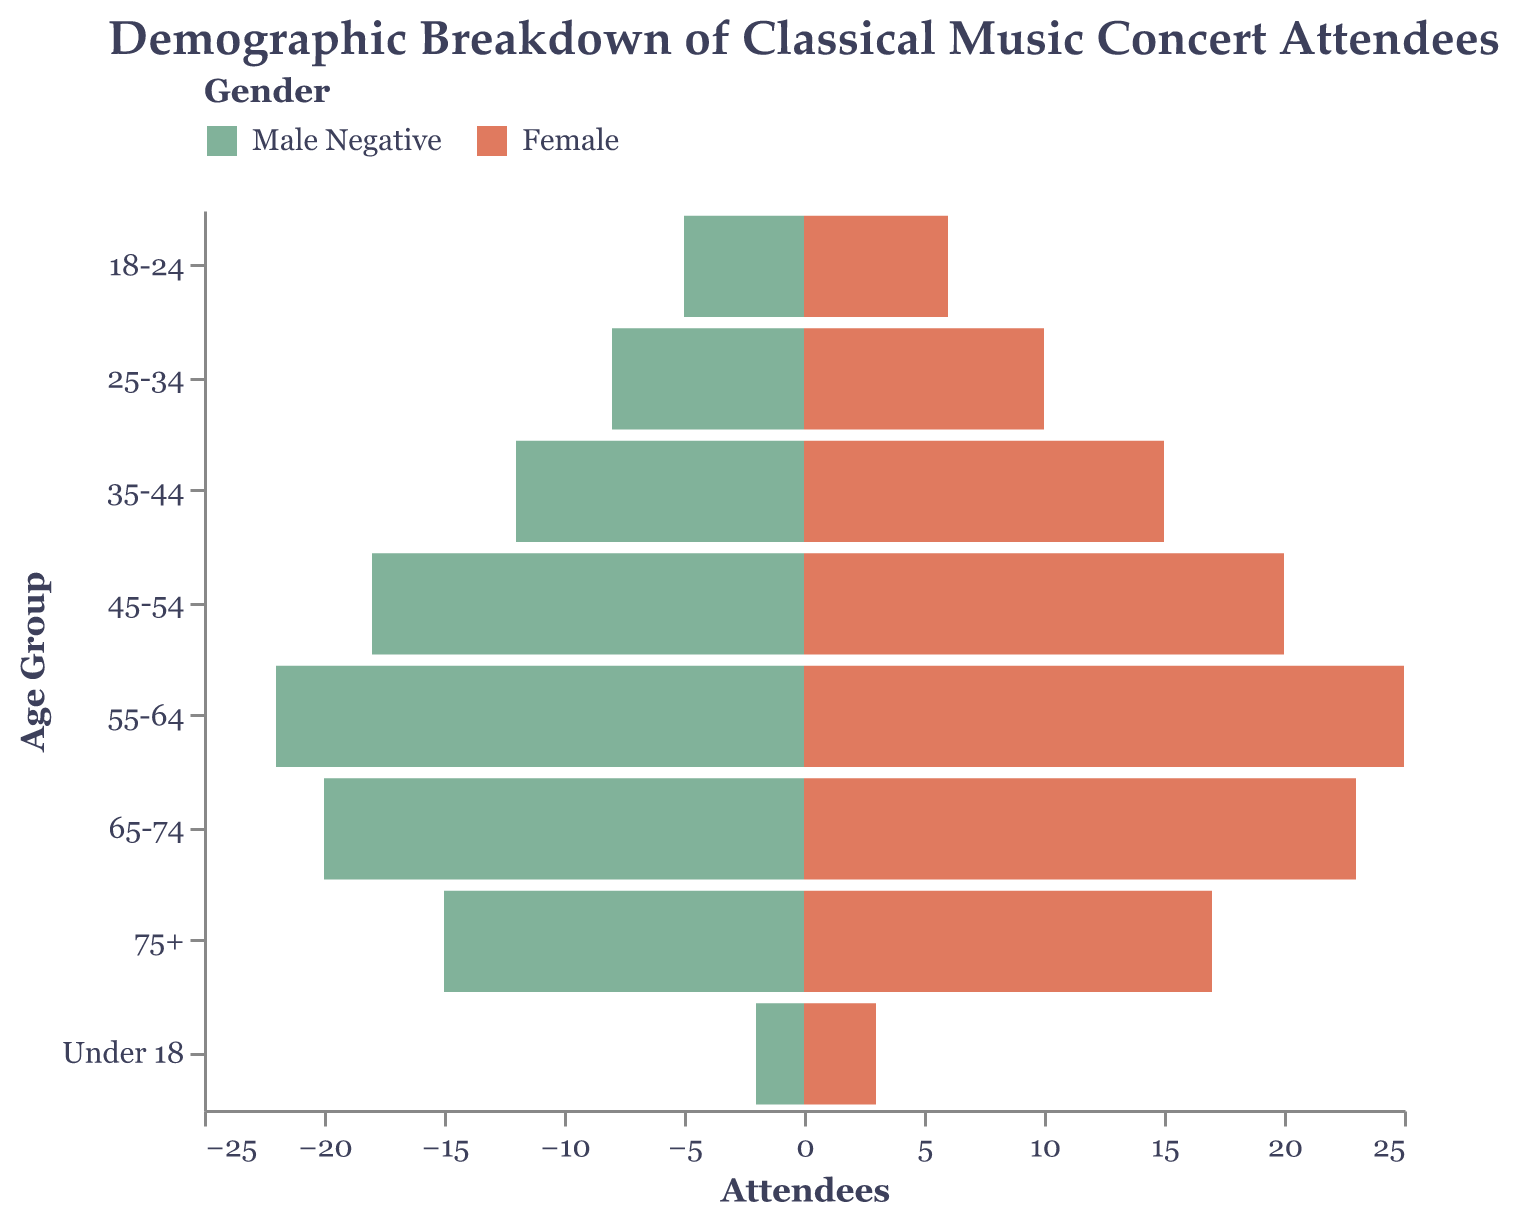What is the title of the figure? The title is usually displayed at the top of the figure. This one reads "Demographic Breakdown of Classical Music Concert Attendees".
Answer: Demographic Breakdown of Classical Music Concert Attendees What are the age groups displayed in the figure? The age groups are listed on the y-axis. The groups are: "Under 18", "18-24", "25-34", "35-44", "45-54", "55-64", "65-74", and "75+".
Answer: Under 18, 18-24, 25-34, 35-44, 45-54, 55-64, 65-74, 75+ What is the color representing male attendees? In the legend, the color representing male attendees is "#81b29a". This is visually distinguishable from the female attendees who are represented by a different color.
Answer: #81b29a How many female attendees are there in the 35-44 age group? Look at the "35-44" age group and find the bar representing female attendees. The figure shows that there are 15 female attendees in this age group.
Answer: 15 Which age group has the highest number of male attendees? Check the length of the male bars across all age groups. The longest male bar corresponds to the "55-64" age group with 22 male attendees.
Answer: 55-64 What is the total number of attendees aged 18-24? Sum up the number of male and female attendees in the "18-24" age group. There are 5 male and 6 female attendees, which adds up to 11.
Answer: 11 What is the difference in the number of attendees between the 45-54 and 65-74 age groups? For the 45-54 age group, there are 18 male and 20 female attendees (total 38). For the 65-74 age group, there are 20 male and 23 female attendees (total 43). The difference is 43 - 38 = 5.
Answer: 5 What is the average number of high-income attendees across all age groups? The numbers of high-income attendees for each age group are: 1, 2, 5, 7, 11, 14, 13, 9. Sum these numbers: 1+2+5+7+11+14+13+9 = 62. There are 8 age groups, so the average is 62 / 8 = 7.75.
Answer: 7.75 How does the representation of low-income attendees change as age increases? Check the "Low Income" column across different age groups. The number of low-income attendees generally increases from (Under 18: 1) to (55-64: 10), then slightly decreases for older groups (65-74: 9, 75+: 7).
Answer: Increases up to 55-64, then decreases Which gender has more attendees in the 75+ age group? Compare the lengths of the bars for male and female attendees in the "75+" age group. There are 15 male and 17 female attendees, so females have more attendees.
Answer: Female 